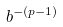Convert formula to latex. <formula><loc_0><loc_0><loc_500><loc_500>b ^ { - ( p - 1 ) }</formula> 